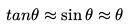<formula> <loc_0><loc_0><loc_500><loc_500>t a n \theta \approx \sin \theta \approx \theta</formula> 